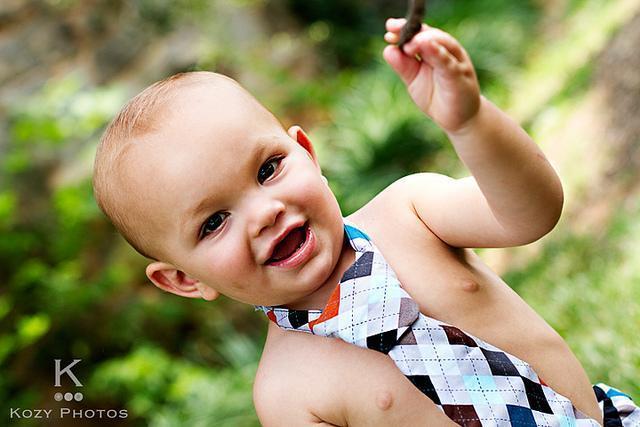How many sheep are there?
Give a very brief answer. 0. 